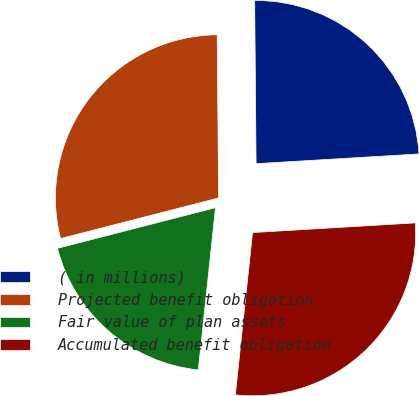Convert chart to OTSL. <chart><loc_0><loc_0><loc_500><loc_500><pie_chart><fcel>( in millions)<fcel>Projected benefit obligation<fcel>Fair value of plan assets<fcel>Accumulated benefit obligation<nl><fcel>24.19%<fcel>28.87%<fcel>19.31%<fcel>27.63%<nl></chart> 